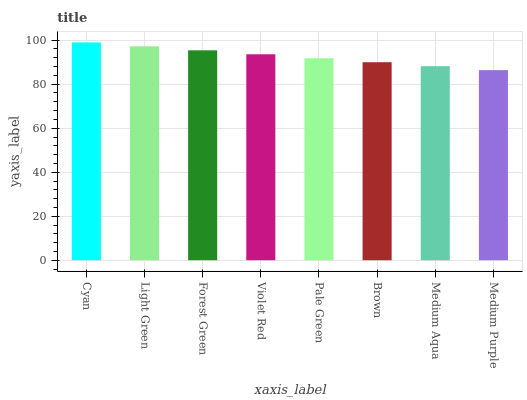Is Medium Purple the minimum?
Answer yes or no. Yes. Is Cyan the maximum?
Answer yes or no. Yes. Is Light Green the minimum?
Answer yes or no. No. Is Light Green the maximum?
Answer yes or no. No. Is Cyan greater than Light Green?
Answer yes or no. Yes. Is Light Green less than Cyan?
Answer yes or no. Yes. Is Light Green greater than Cyan?
Answer yes or no. No. Is Cyan less than Light Green?
Answer yes or no. No. Is Violet Red the high median?
Answer yes or no. Yes. Is Pale Green the low median?
Answer yes or no. Yes. Is Medium Aqua the high median?
Answer yes or no. No. Is Cyan the low median?
Answer yes or no. No. 